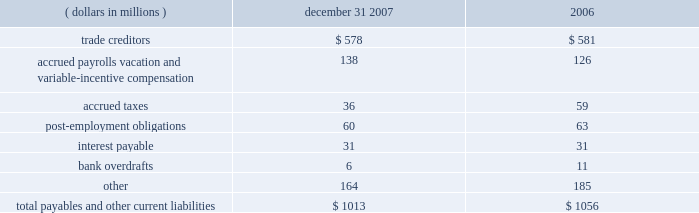Notes to the audited consolidated financial statements 6 .
Equity investments eastman has a 50 percent interest in and serves as the operating partner in primester , a joint venture which manufactures cellulose acetate at eastman's kingsport , tennessee plant .
This investment is accounted for under the equity method .
Eastman's net investment in the joint venture at december 31 , 2007 and 2006 was approximately $ 43 million and $ 47 million , respectively , which was comprised of the recognized portion of the venture's accumulated deficits , long-term amounts owed to primester , and a line of credit from eastman to primester .
Such amounts are included in other noncurrent assets .
Eastman owns a 50 percent interest in nanjing yangzi eastman chemical ltd .
( 201cnanjing 201d ) , a company which manufactures eastotactm hydrocarbon tackifying resins for the adhesives market .
This joint venture is accounted for under the equity method and is included in other noncurrent assets .
At december 31 , 2007 and 2006 , the company 2019s investment in nanjing was approximately $ 7 million and $ 5 million , respectively .
In october 2007 , the company entered into an agreement with green rock energy , l.l.c .
( "green rock" ) , a company formed by the d .
Shaw group and goldman , sachs & co. , to jointly develop the industrial gasification facility in beaumont , texas through tx energy , llc ( "tx energy" ) .
Eastman owns a 50 percent interest in tx energy , which is expected to be operational in 2011 and will produce intermediate chemicals , such as hydrogen , methanol , and ammonia from petroleum coke .
This joint venture in the development stage is accounted for under the equity method , and is included in other noncurrent assets .
At december 31 , 2007 , the company 2019s investment in tx energy was approximately $ 26 million .
Eastman also plans to participate in a project sponsored by faustina hydrogen products , l.l.c .
Which will use petroleum coke as the primary feedstock to make anhydrous ammonia and methanol .
Faustina hydrogen products is primarily owned by green rock .
The company intends to take a 25 percent or greater equity position in the project , provide operations , maintenance , and other site management services , and purchase methanol under a long-term contract .
Capital costs for the facility are estimated to be approximately $ 1.6 billion .
Project financing is expected to be obtained by the end of 2008 .
The facility will be built in st .
James parish , louisiana and is expected to be complete by 2011 .
On april 21 , 2005 , the company completed the sale of its equity investment in genencor international , inc .
( "genencor" ) for cash proceeds of approximately $ 417 million , net of $ 2 million in fees .
The book value of the investment prior to sale was $ 246 million , and the company recorded a pre-tax gain on the sale of $ 171 million .
Payables and other current liabilities december 31 , ( dollars in millions ) 2007 2006 .
The current portion of post-employment obligations is an estimate of current year payments in excess of plan assets. .
What was the ratio of the investment prior to sale to the pre-tax gain on the sale? 
Computations: (246 / 171)
Answer: 1.4386. 